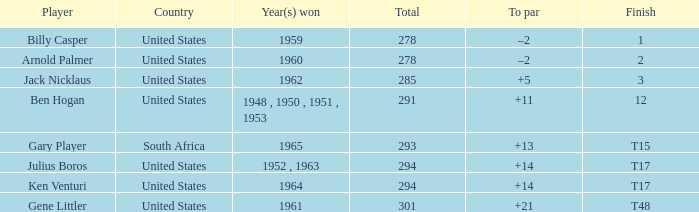What is Finish, when Country is "United States", and when Player is "Julius Boros"? T17. Would you be able to parse every entry in this table? {'header': ['Player', 'Country', 'Year(s) won', 'Total', 'To par', 'Finish'], 'rows': [['Billy Casper', 'United States', '1959', '278', '–2', '1'], ['Arnold Palmer', 'United States', '1960', '278', '–2', '2'], ['Jack Nicklaus', 'United States', '1962', '285', '+5', '3'], ['Ben Hogan', 'United States', '1948 , 1950 , 1951 , 1953', '291', '+11', '12'], ['Gary Player', 'South Africa', '1965', '293', '+13', 'T15'], ['Julius Boros', 'United States', '1952 , 1963', '294', '+14', 'T17'], ['Ken Venturi', 'United States', '1964', '294', '+14', 'T17'], ['Gene Littler', 'United States', '1961', '301', '+21', 'T48']]} 